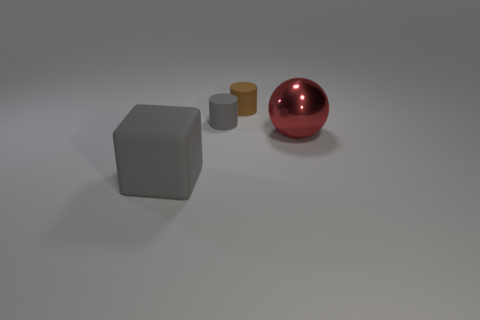Add 2 brown cylinders. How many objects exist? 6 Subtract all blocks. How many objects are left? 3 Add 2 metallic balls. How many metallic balls exist? 3 Subtract 0 blue cylinders. How many objects are left? 4 Subtract all red metal spheres. Subtract all small brown matte cylinders. How many objects are left? 2 Add 4 tiny gray objects. How many tiny gray objects are left? 5 